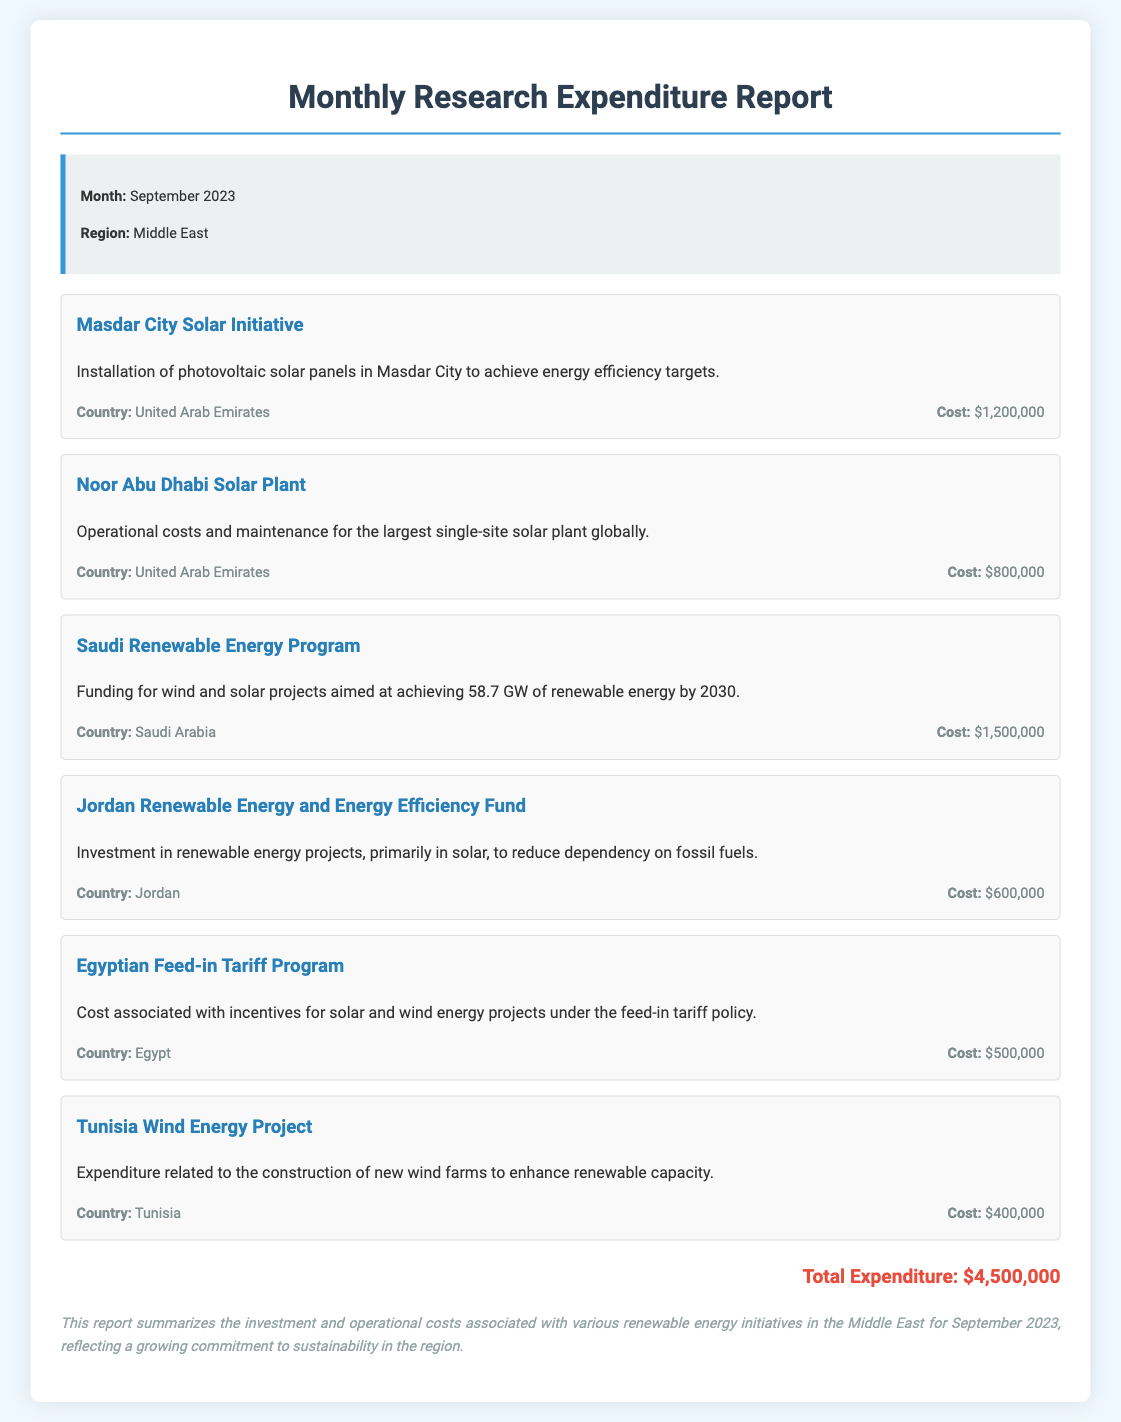What is the total expenditure for September 2023? The total expenditure is provided at the end of the document, summarizing all costs associated with the renewable energy projects listed.
Answer: $4,500,000 What country is associated with the Masdar City Solar Initiative? The document specifies the country for each project, which can be easily found in the project details.
Answer: United Arab Emirates How much was spent on the Saudi Renewable Energy Program? The cost of the Saudi Renewable Energy Program is listed in the project details section, reflecting the funding allocated for the initiative.
Answer: $1,500,000 Which project is related to the construction of new wind farms? Each project description includes a brief statement about its focus, making it clear what each project entails.
Answer: Tunisia Wind Energy Project What was the cost for the Egyptian Feed-in Tariff Program? The document mentions the associated cost under the project title, providing a specific financial figure.
Answer: $500,000 Which initiative aims to reduce dependency on fossil fuels? The project descriptions include the main objectives, clarifying the purpose behind each initiative listed.
Answer: Jordan Renewable Energy and Energy Efficiency Fund What is the purpose of the Noor Abu Dhabi Solar Plant? Each project has a description outlining its primary goals, allowing for easy identification of its purpose.
Answer: Operational costs and maintenance How many projects are listed in the report? By counting the individual project sections in the document, one can determine how many different projects are included.
Answer: Six What was the cost of the Tunisia Wind Energy Project? The financial data for each project is explicitly stated, making it straightforward to extract the necessary information.
Answer: $400,000 